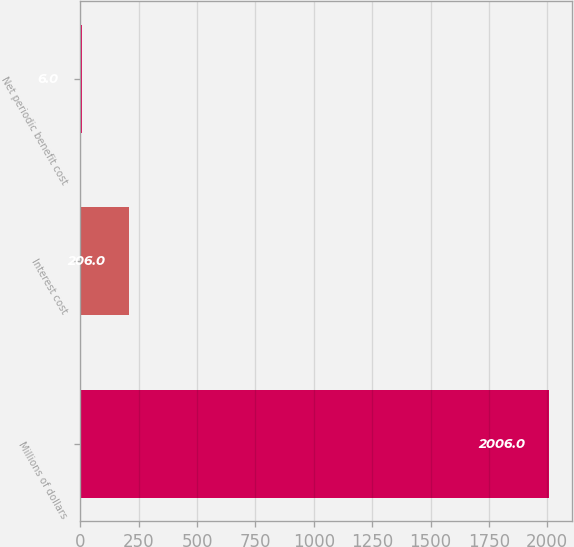Convert chart to OTSL. <chart><loc_0><loc_0><loc_500><loc_500><bar_chart><fcel>Millions of dollars<fcel>Interest cost<fcel>Net periodic benefit cost<nl><fcel>2006<fcel>206<fcel>6<nl></chart> 